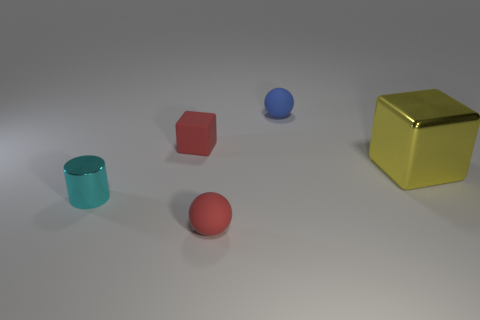Add 1 red balls. How many objects exist? 6 Subtract all large purple metal spheres. Subtract all cylinders. How many objects are left? 4 Add 1 small blue things. How many small blue things are left? 2 Add 5 small matte balls. How many small matte balls exist? 7 Subtract 0 cyan cubes. How many objects are left? 5 Subtract all cylinders. How many objects are left? 4 